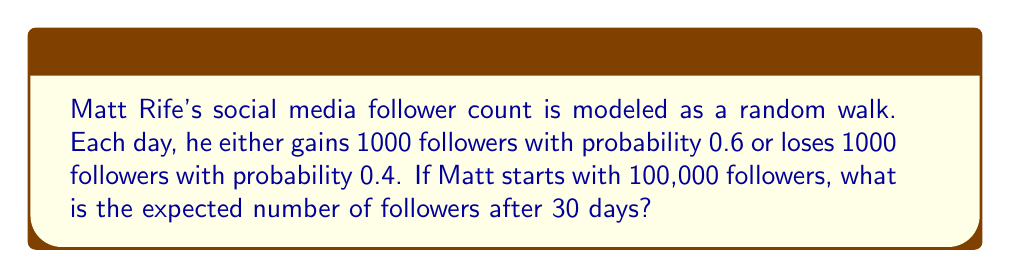Can you answer this question? Let's approach this step-by-step:

1) This is a random walk with two possible outcomes each day:
   - Gain 1000 followers (probability 0.6)
   - Lose 1000 followers (probability 0.4)

2) The expected change in followers per day is:
   $$(1000 \times 0.6) + (-1000 \times 0.4) = 600 - 400 = 200$$

3) This means, on average, Matt gains 200 followers per day.

4) Over 30 days, the expected total change in followers is:
   $$200 \times 30 = 6000$$

5) Starting with 100,000 followers, the expected number after 30 days is:
   $$100,000 + 6000 = 106,000$$

6) We can also express this using the formula for the expected position in a random walk:
   $$E[X_n] = X_0 + n(p_1\Delta_1 + p_2\Delta_2)$$
   
   Where:
   $X_0$ is the initial position (100,000)
   $n$ is the number of steps (30)
   $p_1$ and $p_2$ are the probabilities (0.6 and 0.4)
   $\Delta_1$ and $\Delta_2$ are the step sizes (1000 and -1000)

   $$E[X_{30}] = 100,000 + 30(0.6 \times 1000 + 0.4 \times (-1000)) = 106,000$$
Answer: 106,000 followers 